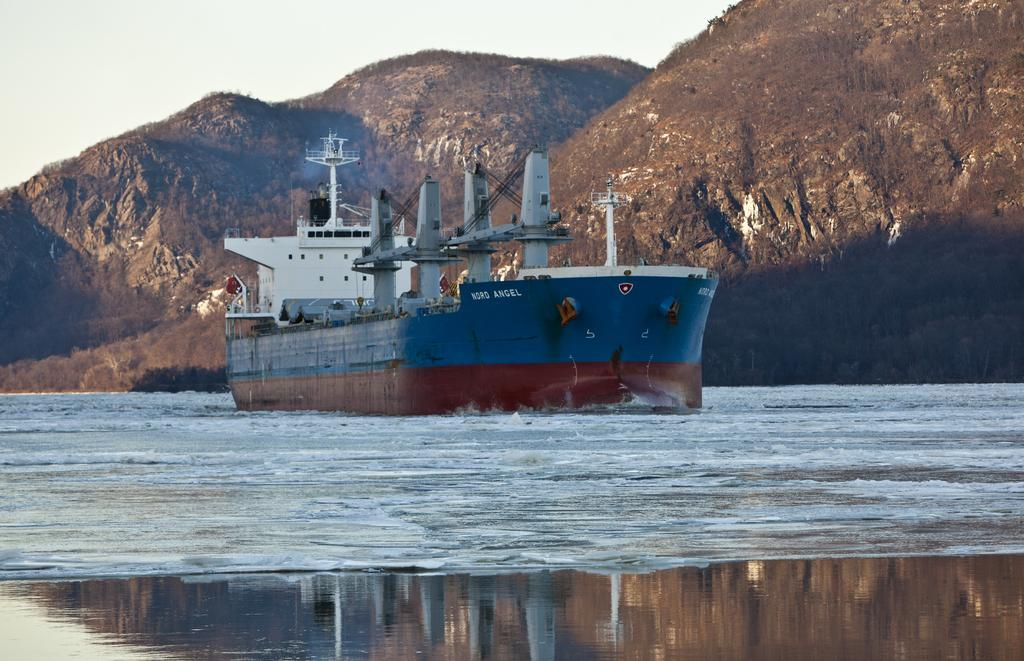Where was the picture taken? The picture was clicked outside. What can be seen in the water body in the image? There is a ship in the water body. What type of natural feature is visible in the background of the image? There are hills visible in the background. What part of the sky is visible in the image? The sky is visible in the background of the image. What is the name of the committee that organized the event on the ship in the image? There is no event or committee mentioned in the image; it only shows a ship in a water body with hills and sky in the background. 